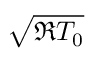Convert formula to latex. <formula><loc_0><loc_0><loc_500><loc_500>\sqrt { \mathfrak { R } T _ { 0 } }</formula> 